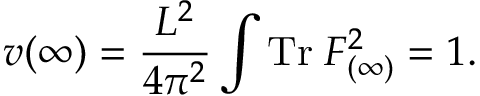<formula> <loc_0><loc_0><loc_500><loc_500>v ( \infty ) = \frac { L ^ { 2 } } { 4 \pi ^ { 2 } } \int T r \, F _ { ( \infty ) } ^ { 2 } = 1 .</formula> 